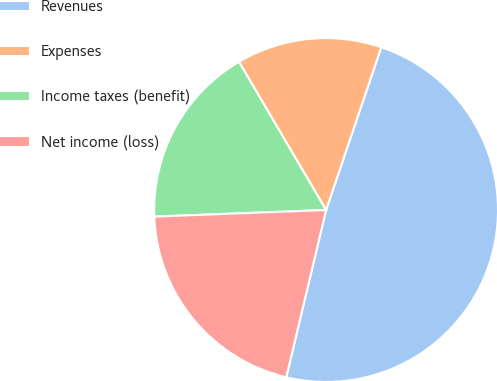Convert chart. <chart><loc_0><loc_0><loc_500><loc_500><pie_chart><fcel>Revenues<fcel>Expenses<fcel>Income taxes (benefit)<fcel>Net income (loss)<nl><fcel>48.52%<fcel>13.66%<fcel>17.15%<fcel>20.67%<nl></chart> 